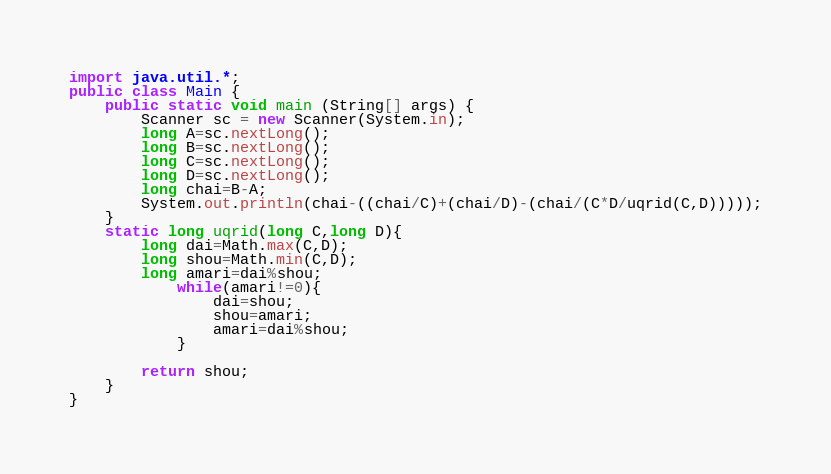<code> <loc_0><loc_0><loc_500><loc_500><_Java_>import java.util.*;
public class Main {
	public static void main (String[] args) {
		Scanner sc = new Scanner(System.in);
		long A=sc.nextLong();
		long B=sc.nextLong();
		long C=sc.nextLong();
		long D=sc.nextLong();
      	long chai=B-A;
		System.out.println(chai-((chai/C)+(chai/D)-(chai/(C*D/uqrid(C,D)))));
	}
	static long uqrid(long C,long D){
		long dai=Math.max(C,D);
		long shou=Math.min(C,D);
		long amari=dai%shou;
 	     	while(amari!=0){
				dai=shou;
				shou=amari;
				amari=dai%shou;
			}
        
		return shou;
    }
}
</code> 